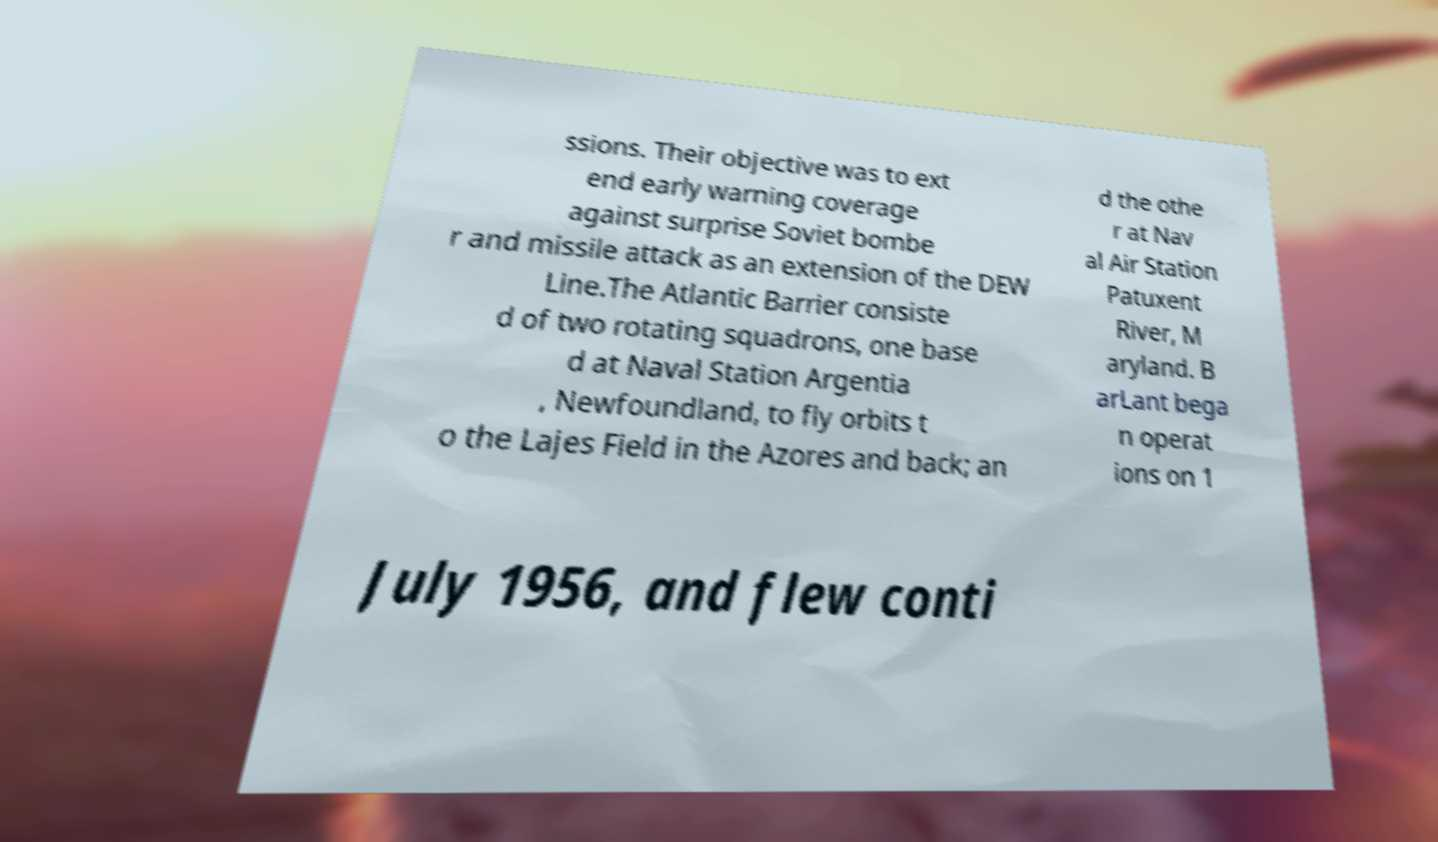Could you extract and type out the text from this image? ssions. Their objective was to ext end early warning coverage against surprise Soviet bombe r and missile attack as an extension of the DEW Line.The Atlantic Barrier consiste d of two rotating squadrons, one base d at Naval Station Argentia , Newfoundland, to fly orbits t o the Lajes Field in the Azores and back; an d the othe r at Nav al Air Station Patuxent River, M aryland. B arLant bega n operat ions on 1 July 1956, and flew conti 